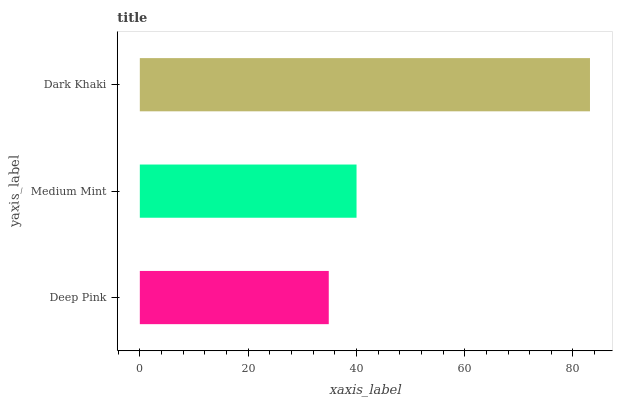Is Deep Pink the minimum?
Answer yes or no. Yes. Is Dark Khaki the maximum?
Answer yes or no. Yes. Is Medium Mint the minimum?
Answer yes or no. No. Is Medium Mint the maximum?
Answer yes or no. No. Is Medium Mint greater than Deep Pink?
Answer yes or no. Yes. Is Deep Pink less than Medium Mint?
Answer yes or no. Yes. Is Deep Pink greater than Medium Mint?
Answer yes or no. No. Is Medium Mint less than Deep Pink?
Answer yes or no. No. Is Medium Mint the high median?
Answer yes or no. Yes. Is Medium Mint the low median?
Answer yes or no. Yes. Is Deep Pink the high median?
Answer yes or no. No. Is Dark Khaki the low median?
Answer yes or no. No. 